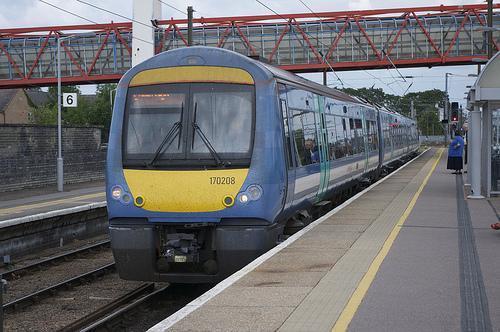How many people in the picture?
Give a very brief answer. 1. 